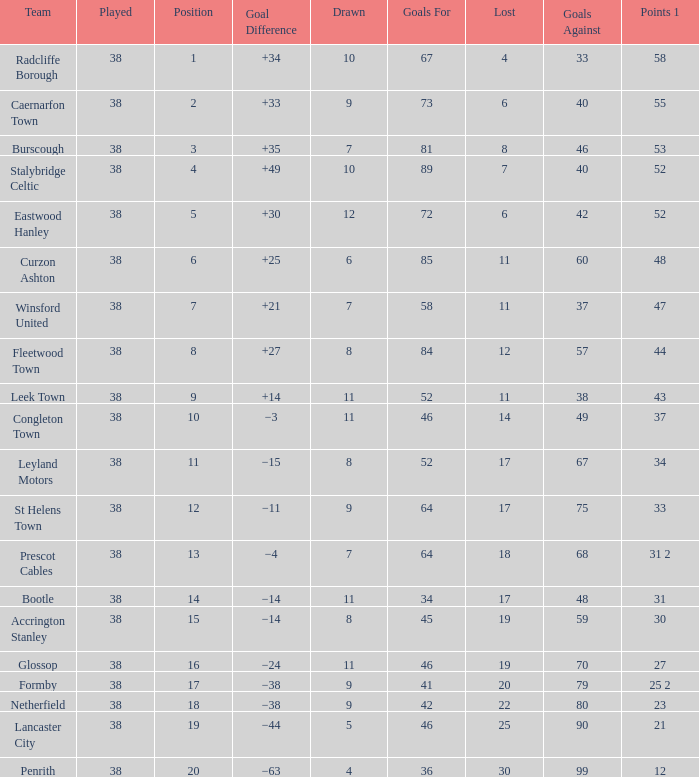WHAT POINTS 1 HAD A 22 LOST? 23.0. 